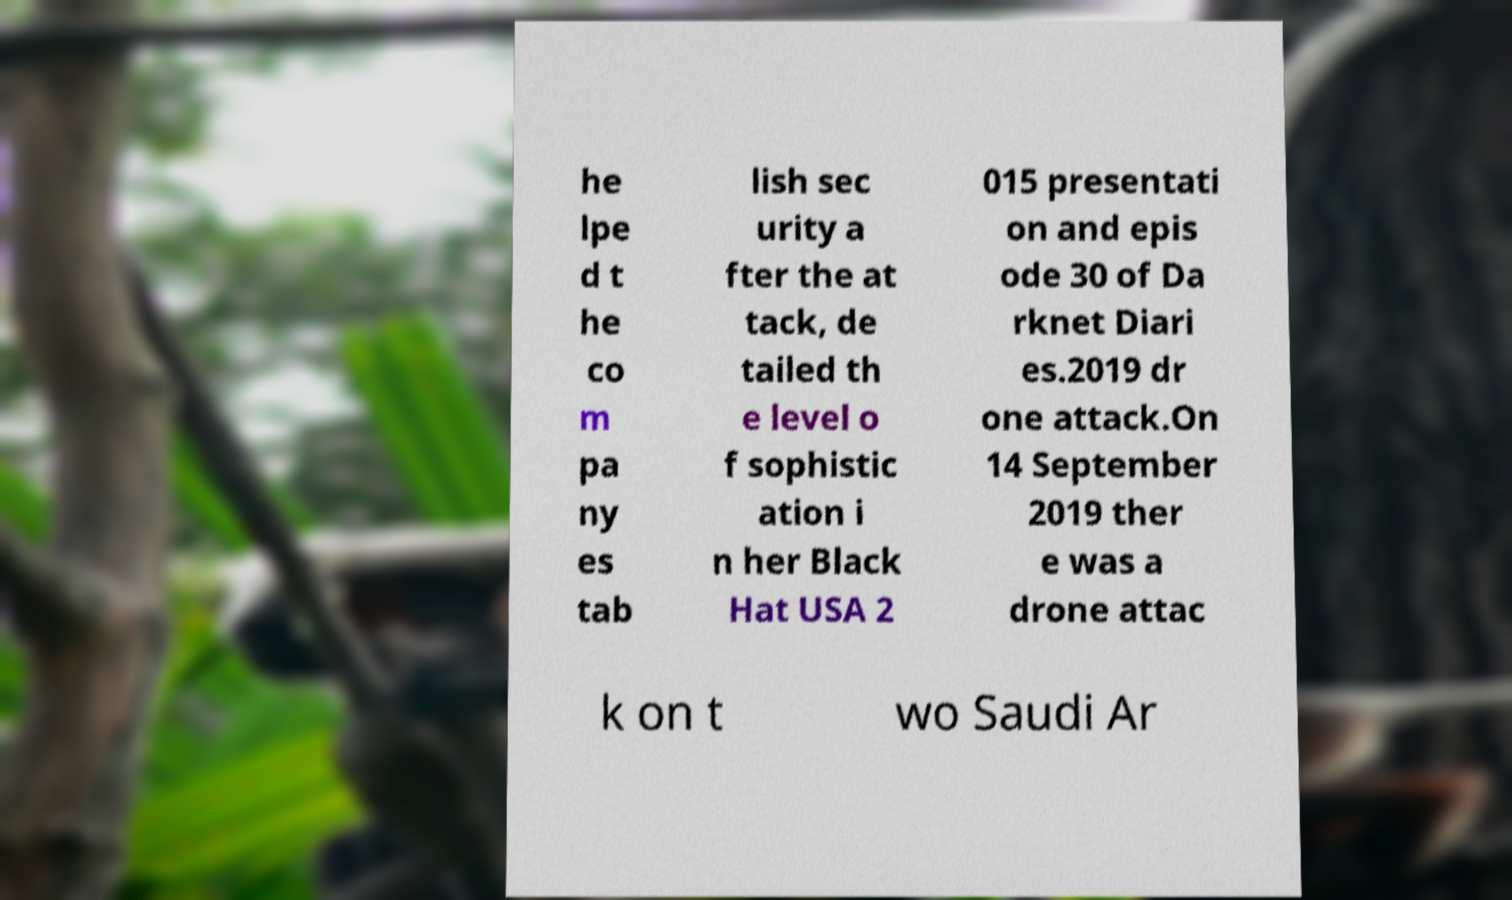Can you accurately transcribe the text from the provided image for me? he lpe d t he co m pa ny es tab lish sec urity a fter the at tack, de tailed th e level o f sophistic ation i n her Black Hat USA 2 015 presentati on and epis ode 30 of Da rknet Diari es.2019 dr one attack.On 14 September 2019 ther e was a drone attac k on t wo Saudi Ar 